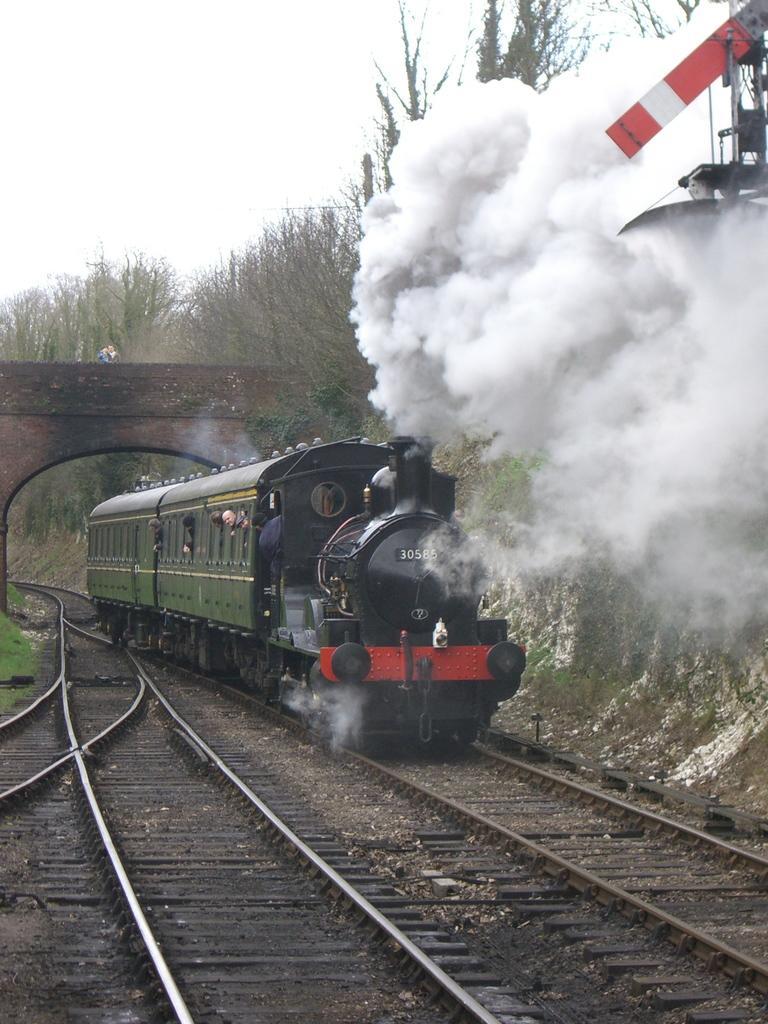Describe this image in one or two sentences. As we can see in the image there is a railway track, train, smoke, trees and sky. 